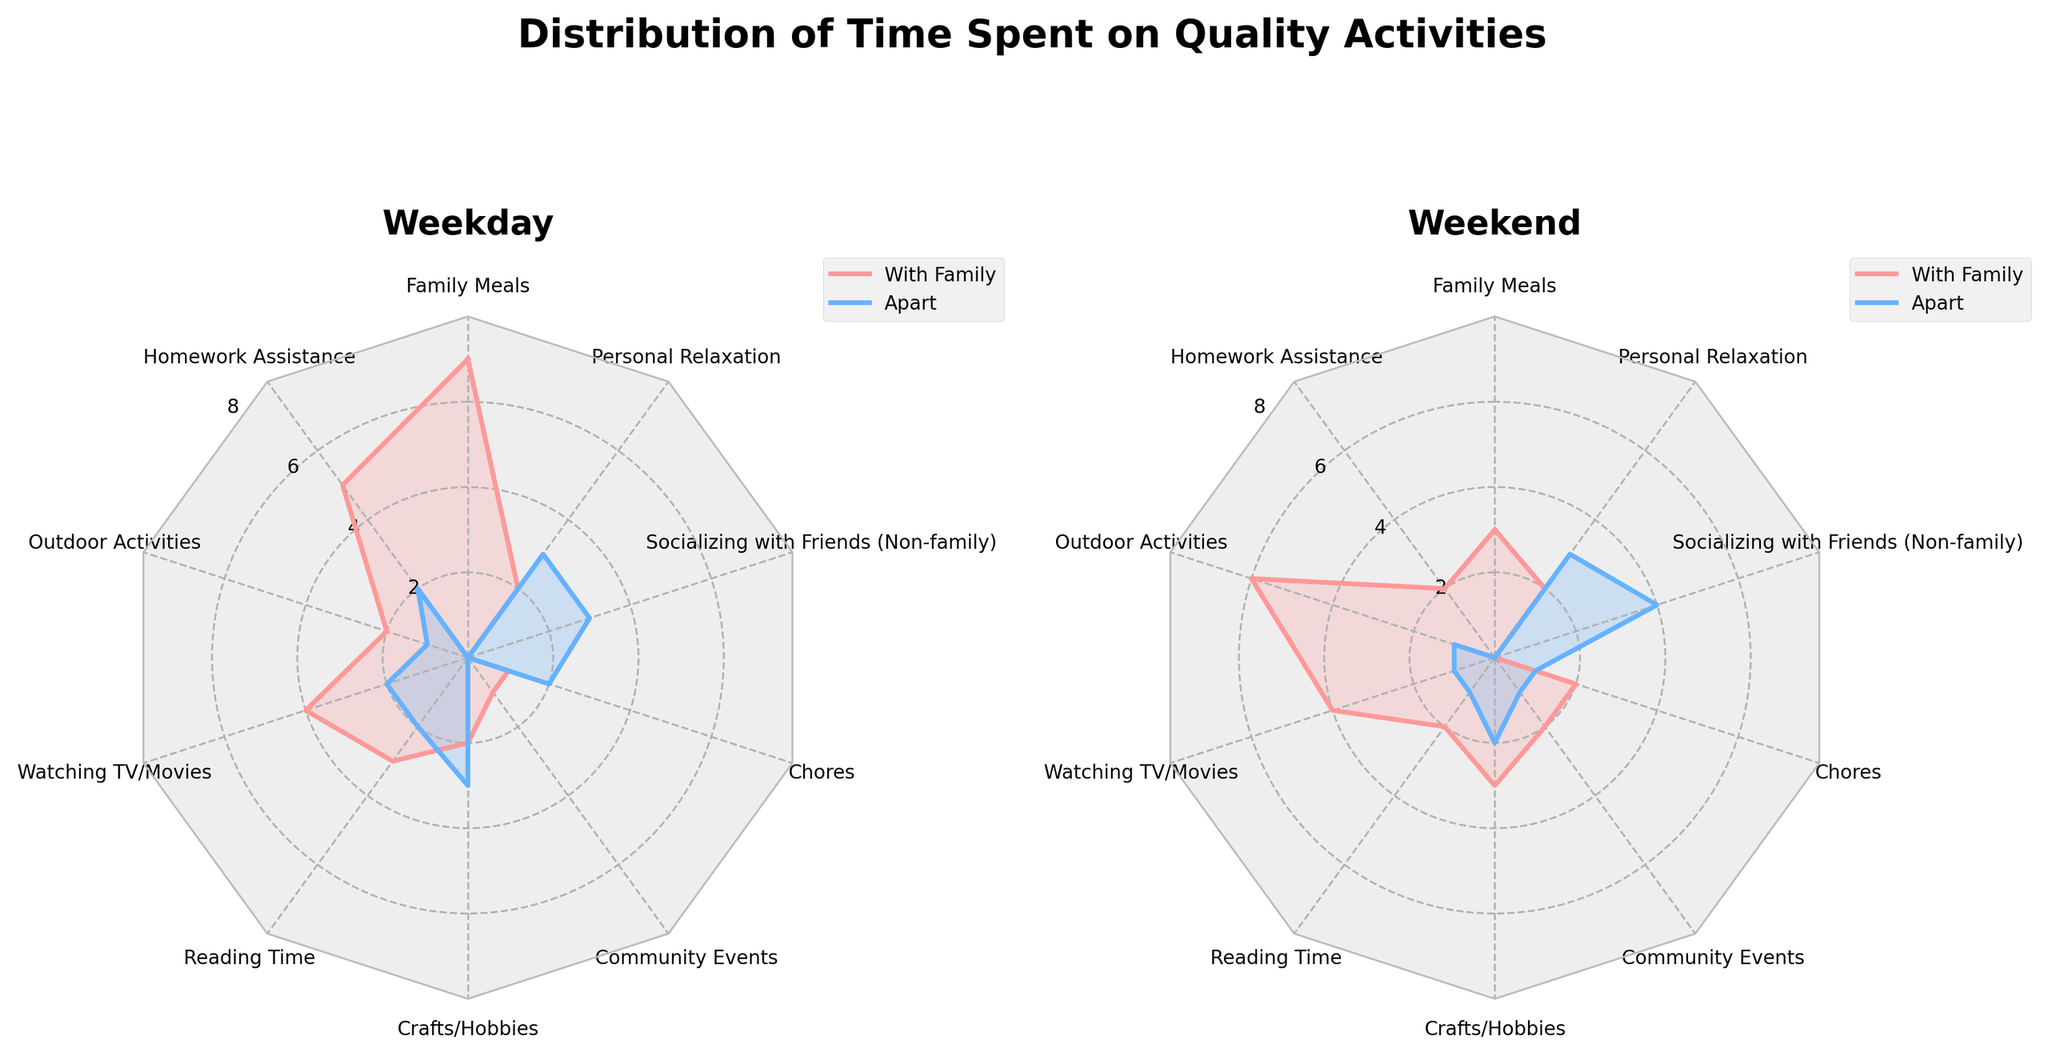What are the main colors used to represent "Weekday Hours with Family" and "Weekday Hours Apart" in the plot? From the plot, the color used for "Weekday Hours with Family" is similar to a light pinkish tone, and for "Weekday Hours Apart," it is a light blue tone. These colors help distinguish between the two categories.
Answer: Light pinkish and light blue What activity has the highest number of weekday hours spent with family? Observe the radar chart for weekday hours spent with family. "Family Meals" segment reaches the outermost point on the chart, indicating it has the highest value.
Answer: Family Meals How many hours are spent on "Homework Assistance" apart from the family on weekdays? Refer to the weekday subplot and find the "Homework Assistance" segment. The radar plot shows the value as 2 hours.
Answer: 2 hours On weekends, which activity shows a more significant difference between hours with family and hours apart? Compare the lengths of the segments for each activity under weekend hours with and apart from the family. "Socializing with Friends (Non-family)" shows 0 hours with family and 4 hours apart, which is the largest difference.
Answer: Socializing with Friends (Non-family) Considering both weekdays and weekends, which activity is consistently done more with family than apart? Reviewing both radar charts, "Family Meals" is consistently done with family (7 hours on weekdays, 3 hours on weekends) and has 0 hours apart in both cases.
Answer: Family Meals Which activity has the maximum hours spent apart from family on weekends? Check the segment lengths in the weekend radar chart for hours apart from family. "Socializing with Friends (Non-family)" has the highest value with 4 hours.
Answer: Socializing with Friends (Non-family) What's the total amount of hours spent on "Outdoor Activities" on both weekdays and weekends with family? Sum the hours spent on "Outdoor Activities" with family on weekdays and weekends. Weekdays is 2 hours, and weekends is 6 hours. So, the total is 2 + 6 = 8 hours.
Answer: 8 hours Which has more hours dedicated to chores, weekdays or weekends? The radar chart shows 1 hour on weekdays and 2 hours on weekends spent on chores with family.
Answer: Weekends How do the total weekday "with family" hours compare to weekend "with family" hours in the chart? Sum the weekday hours with family: 7 (Family Meals) + 5 (Homework Assistance) + 2 (Outdoor Activities) + 4 (Watching TV/Movies) + 3 (Reading Time) + 2 (Crafts/Hobbies) + 1 (Community Events) + 1 (Chores) + 0 (Socializing) + 2 (Personal Relaxation) = 27 hours. Sum the weekend hours with family: 3 + 2 + 6 + 4 + 2 + 3 + 2 + 2 + 0 + 2 = 26 hours. Therefore, weekdays have 1 more hour than weekends.
Answer: Weekdays have 1 hour more 